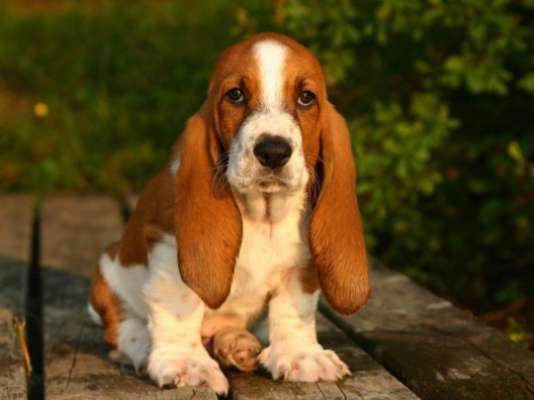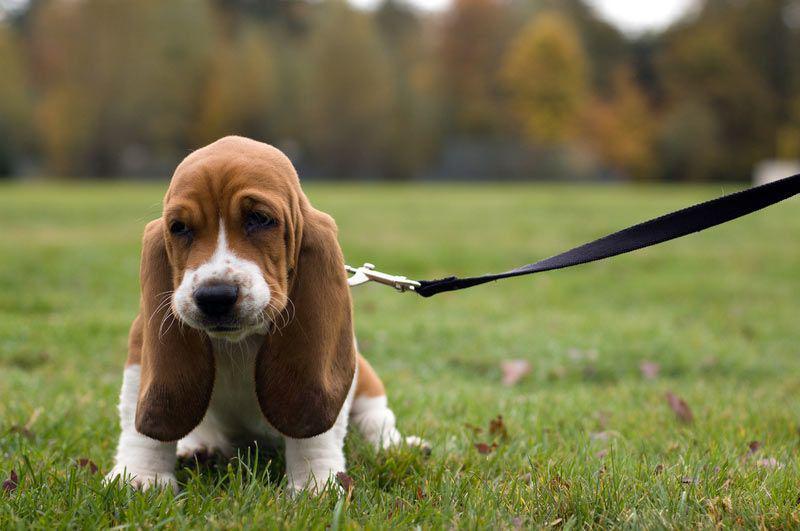The first image is the image on the left, the second image is the image on the right. Evaluate the accuracy of this statement regarding the images: "At least one of the dogs is outside.". Is it true? Answer yes or no. Yes. The first image is the image on the left, the second image is the image on the right. Evaluate the accuracy of this statement regarding the images: "There is green vegetation visible in the background of at least one of the images.". Is it true? Answer yes or no. Yes. 